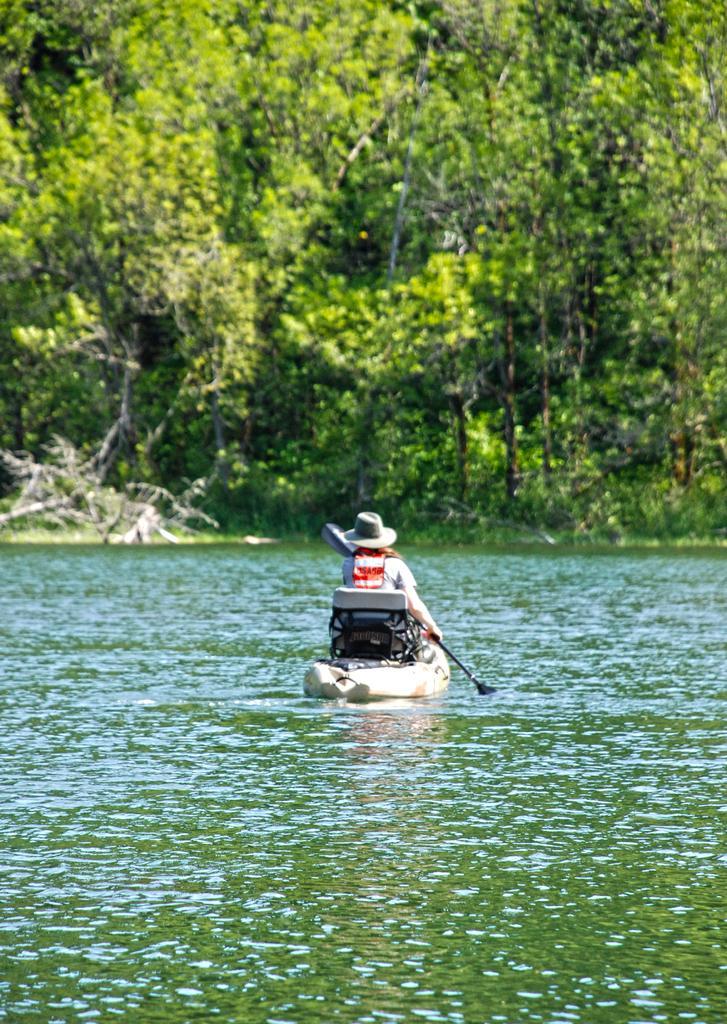Describe this image in one or two sentences. In the image there is a person rowing boat in the middle of lake and in the background there are trees. 